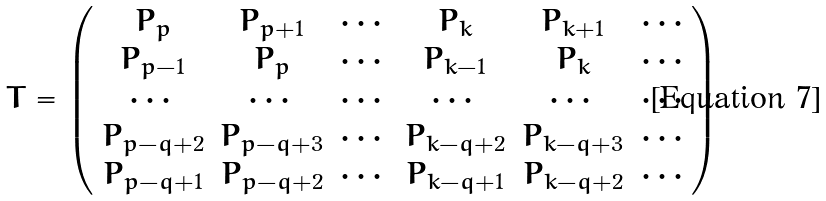<formula> <loc_0><loc_0><loc_500><loc_500>T = \left ( \begin{array} { c c c c c c } P _ { p } & P _ { p + 1 } & \cdots & P _ { k } & P _ { k + 1 } & \cdots \\ P _ { p - 1 } & P _ { p } & \cdots & P _ { k - 1 } & P _ { k } & \cdots \\ \cdots & \cdots & \cdots & \cdots & \cdots & \cdots \\ P _ { p - q + 2 } & P _ { p - q + 3 } & \cdots & P _ { k - q + 2 } & P _ { k - q + 3 } & \cdots \\ P _ { p - q + 1 } & P _ { p - q + 2 } & \cdots & P _ { k - q + 1 } & P _ { k - q + 2 } & \cdots \end{array} \right )</formula> 